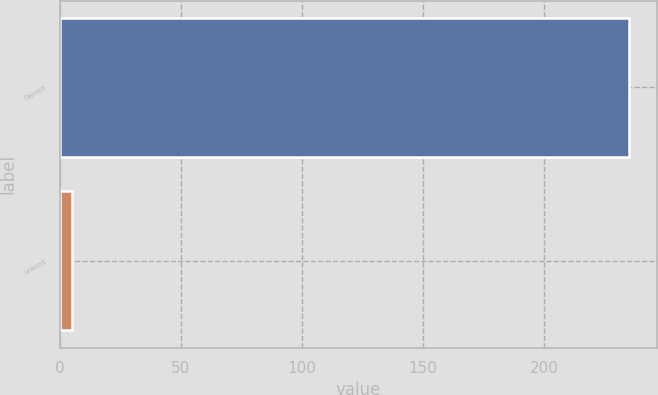Convert chart. <chart><loc_0><loc_0><loc_500><loc_500><bar_chart><fcel>Owned<fcel>Leased<nl><fcel>235<fcel>5<nl></chart> 